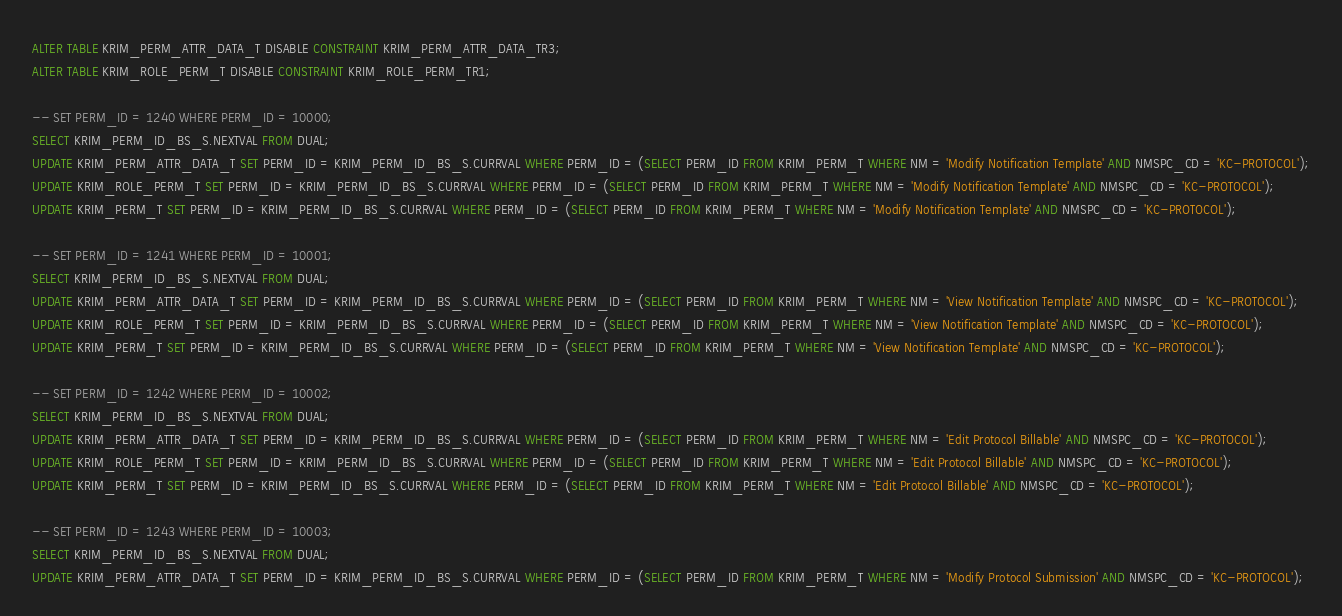<code> <loc_0><loc_0><loc_500><loc_500><_SQL_>ALTER TABLE KRIM_PERM_ATTR_DATA_T DISABLE CONSTRAINT KRIM_PERM_ATTR_DATA_TR3;
ALTER TABLE KRIM_ROLE_PERM_T DISABLE CONSTRAINT KRIM_ROLE_PERM_TR1;

-- SET PERM_ID = 1240 WHERE PERM_ID = 10000;
SELECT KRIM_PERM_ID_BS_S.NEXTVAL FROM DUAL;
UPDATE KRIM_PERM_ATTR_DATA_T SET PERM_ID = KRIM_PERM_ID_BS_S.CURRVAL WHERE PERM_ID = (SELECT PERM_ID FROM KRIM_PERM_T WHERE NM = 'Modify Notification Template' AND NMSPC_CD = 'KC-PROTOCOL');
UPDATE KRIM_ROLE_PERM_T SET PERM_ID = KRIM_PERM_ID_BS_S.CURRVAL WHERE PERM_ID = (SELECT PERM_ID FROM KRIM_PERM_T WHERE NM = 'Modify Notification Template' AND NMSPC_CD = 'KC-PROTOCOL');
UPDATE KRIM_PERM_T SET PERM_ID = KRIM_PERM_ID_BS_S.CURRVAL WHERE PERM_ID = (SELECT PERM_ID FROM KRIM_PERM_T WHERE NM = 'Modify Notification Template' AND NMSPC_CD = 'KC-PROTOCOL');

-- SET PERM_ID = 1241 WHERE PERM_ID = 10001;
SELECT KRIM_PERM_ID_BS_S.NEXTVAL FROM DUAL;
UPDATE KRIM_PERM_ATTR_DATA_T SET PERM_ID = KRIM_PERM_ID_BS_S.CURRVAL WHERE PERM_ID = (SELECT PERM_ID FROM KRIM_PERM_T WHERE NM = 'View Notification Template' AND NMSPC_CD = 'KC-PROTOCOL'); 
UPDATE KRIM_ROLE_PERM_T SET PERM_ID = KRIM_PERM_ID_BS_S.CURRVAL WHERE PERM_ID = (SELECT PERM_ID FROM KRIM_PERM_T WHERE NM = 'View Notification Template' AND NMSPC_CD = 'KC-PROTOCOL');
UPDATE KRIM_PERM_T SET PERM_ID = KRIM_PERM_ID_BS_S.CURRVAL WHERE PERM_ID = (SELECT PERM_ID FROM KRIM_PERM_T WHERE NM = 'View Notification Template' AND NMSPC_CD = 'KC-PROTOCOL');

-- SET PERM_ID = 1242 WHERE PERM_ID = 10002;
SELECT KRIM_PERM_ID_BS_S.NEXTVAL FROM DUAL;
UPDATE KRIM_PERM_ATTR_DATA_T SET PERM_ID = KRIM_PERM_ID_BS_S.CURRVAL WHERE PERM_ID = (SELECT PERM_ID FROM KRIM_PERM_T WHERE NM = 'Edit Protocol Billable' AND NMSPC_CD = 'KC-PROTOCOL');
UPDATE KRIM_ROLE_PERM_T SET PERM_ID = KRIM_PERM_ID_BS_S.CURRVAL WHERE PERM_ID = (SELECT PERM_ID FROM KRIM_PERM_T WHERE NM = 'Edit Protocol Billable' AND NMSPC_CD = 'KC-PROTOCOL');
UPDATE KRIM_PERM_T SET PERM_ID = KRIM_PERM_ID_BS_S.CURRVAL WHERE PERM_ID = (SELECT PERM_ID FROM KRIM_PERM_T WHERE NM = 'Edit Protocol Billable' AND NMSPC_CD = 'KC-PROTOCOL');

-- SET PERM_ID = 1243 WHERE PERM_ID = 10003;
SELECT KRIM_PERM_ID_BS_S.NEXTVAL FROM DUAL;
UPDATE KRIM_PERM_ATTR_DATA_T SET PERM_ID = KRIM_PERM_ID_BS_S.CURRVAL WHERE PERM_ID = (SELECT PERM_ID FROM KRIM_PERM_T WHERE NM = 'Modify Protocol Submission' AND NMSPC_CD = 'KC-PROTOCOL');</code> 